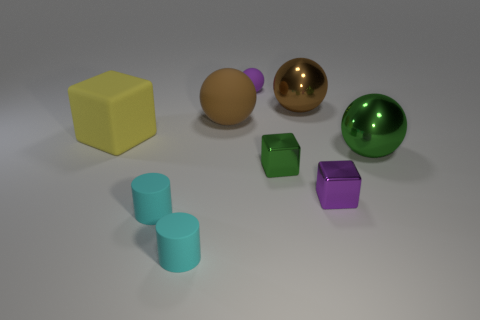Subtract all matte blocks. How many blocks are left? 2 Subtract all cyan cubes. How many brown balls are left? 2 Subtract 2 balls. How many balls are left? 2 Add 1 small cyan metallic cylinders. How many objects exist? 10 Subtract all purple spheres. How many spheres are left? 3 Subtract all cylinders. How many objects are left? 7 Subtract all red spheres. Subtract all green cylinders. How many spheres are left? 4 Add 4 purple objects. How many purple objects exist? 6 Subtract 0 gray blocks. How many objects are left? 9 Subtract all brown rubber spheres. Subtract all green metal cubes. How many objects are left? 7 